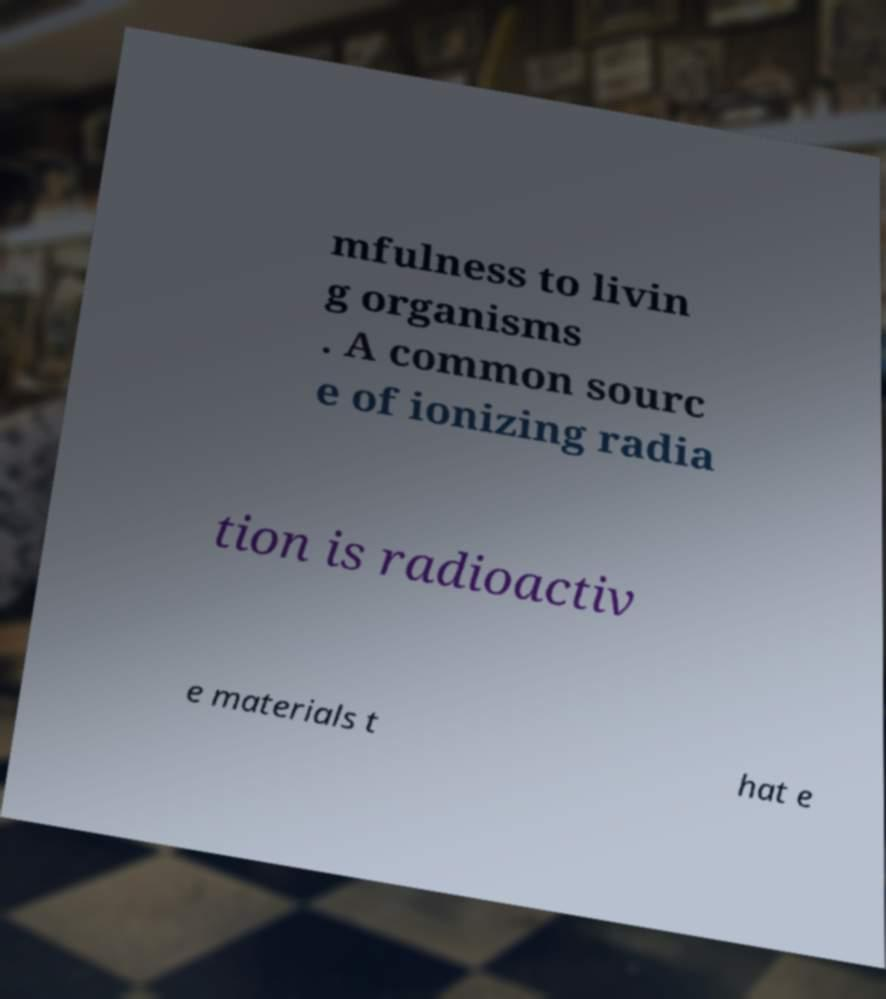There's text embedded in this image that I need extracted. Can you transcribe it verbatim? mfulness to livin g organisms . A common sourc e of ionizing radia tion is radioactiv e materials t hat e 